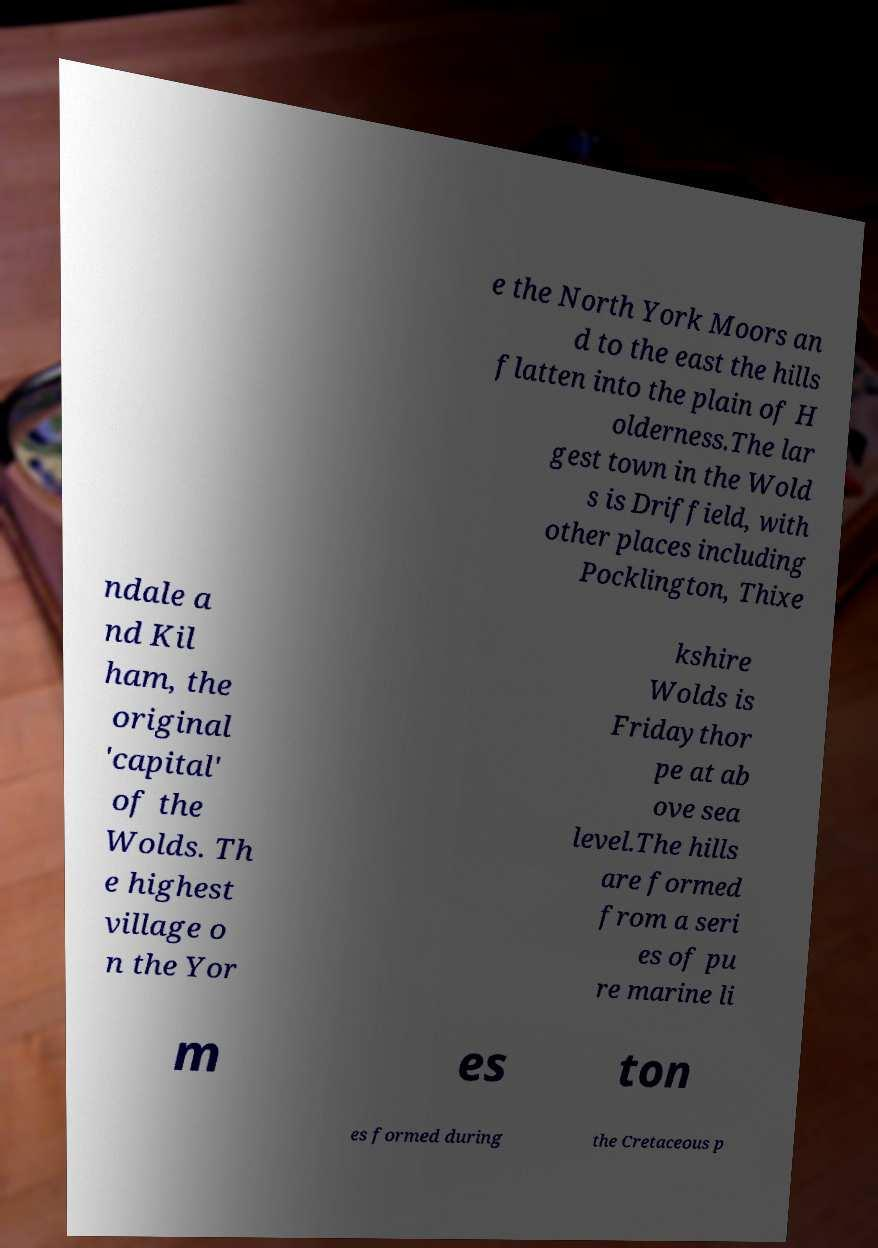Please read and relay the text visible in this image. What does it say? e the North York Moors an d to the east the hills flatten into the plain of H olderness.The lar gest town in the Wold s is Driffield, with other places including Pocklington, Thixe ndale a nd Kil ham, the original 'capital' of the Wolds. Th e highest village o n the Yor kshire Wolds is Fridaythor pe at ab ove sea level.The hills are formed from a seri es of pu re marine li m es ton es formed during the Cretaceous p 